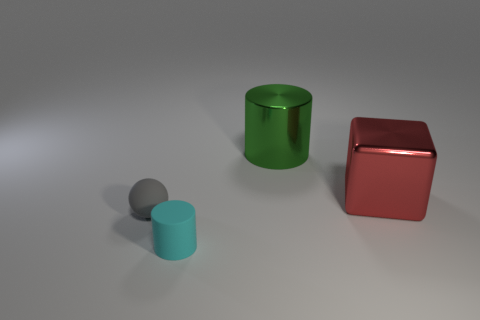Is there any other thing that has the same shape as the large red thing?
Offer a very short reply. No. Are there fewer large red metal things than things?
Your answer should be compact. Yes. There is a thing that is both to the right of the small gray ball and in front of the cube; how big is it?
Make the answer very short. Small. What is the size of the cylinder in front of the cylinder behind the small cylinder that is in front of the large cylinder?
Provide a succinct answer. Small. How many other objects are there of the same color as the rubber sphere?
Provide a succinct answer. 0. How many objects are either matte things or things?
Keep it short and to the point. 4. There is a cylinder behind the small cylinder; what is its color?
Offer a very short reply. Green. Is the number of cyan things behind the green cylinder less than the number of red metal objects?
Ensure brevity in your answer.  Yes. Do the gray ball and the big red block have the same material?
Offer a terse response. No. How many things are large shiny objects that are on the left side of the metal cube or small cyan cylinders that are left of the red object?
Your answer should be compact. 2. 